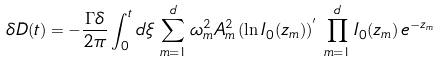<formula> <loc_0><loc_0><loc_500><loc_500>\delta D ( t ) = - \frac { \Gamma \delta } { 2 \pi } \int _ { 0 } ^ { t } d \xi \, \sum _ { m = 1 } ^ { d } \omega _ { m } ^ { 2 } A ^ { 2 } _ { m } \, ( \ln I _ { 0 } ( z _ { m } ) ) ^ { ^ { \prime } } \, \prod _ { m = 1 } ^ { d } I _ { 0 } ( z _ { m } ) \, e ^ { - z _ { m } }</formula> 